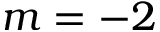<formula> <loc_0><loc_0><loc_500><loc_500>m = - 2</formula> 